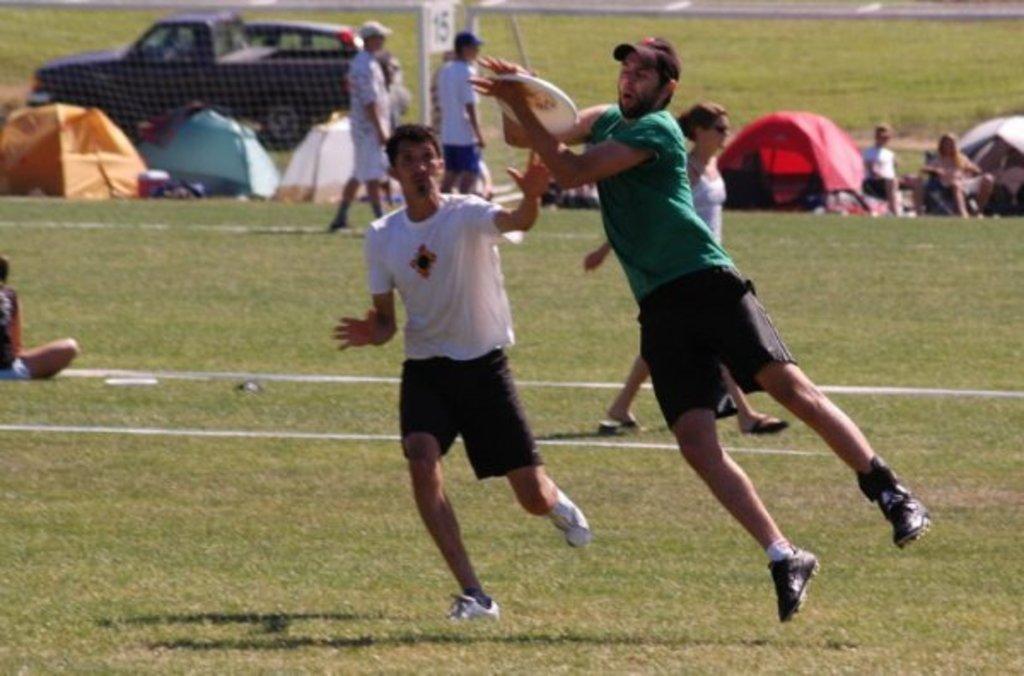In one or two sentences, can you explain what this image depicts? In this image in the foreground there are some people who are playing some game, and one person is holding something. At the bottom there is grass, and in the background there are group of people sitting and watching the game and also there are some tents, net, pole and car. 